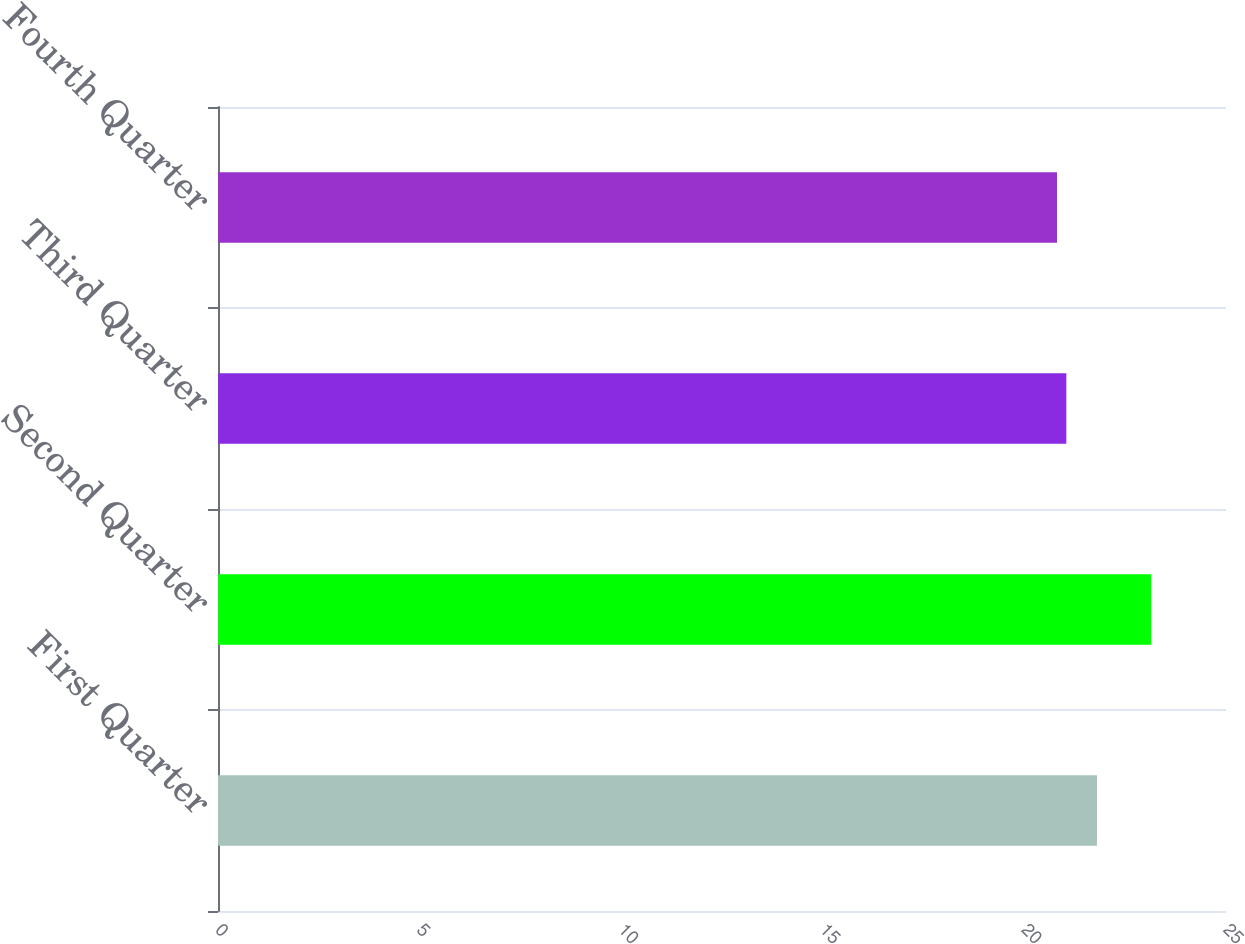Convert chart to OTSL. <chart><loc_0><loc_0><loc_500><loc_500><bar_chart><fcel>First Quarter<fcel>Second Quarter<fcel>Third Quarter<fcel>Fourth Quarter<nl><fcel>21.8<fcel>23.15<fcel>21.04<fcel>20.81<nl></chart> 